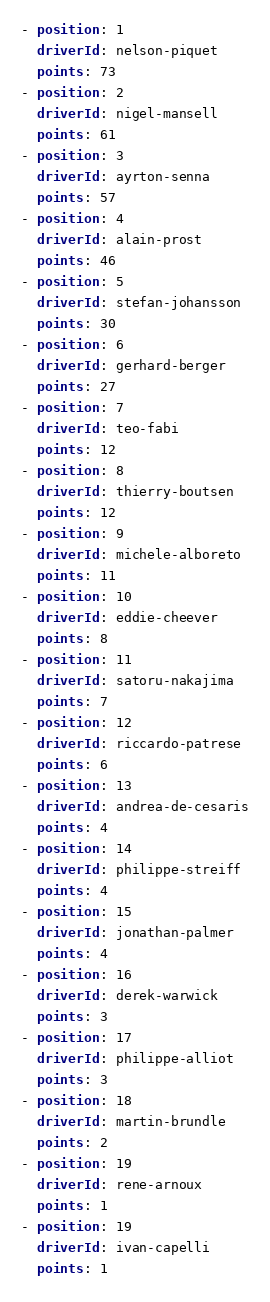Convert code to text. <code><loc_0><loc_0><loc_500><loc_500><_YAML_>- position: 1
  driverId: nelson-piquet
  points: 73
- position: 2
  driverId: nigel-mansell
  points: 61
- position: 3
  driverId: ayrton-senna
  points: 57
- position: 4
  driverId: alain-prost
  points: 46
- position: 5
  driverId: stefan-johansson
  points: 30
- position: 6
  driverId: gerhard-berger
  points: 27
- position: 7
  driverId: teo-fabi
  points: 12
- position: 8
  driverId: thierry-boutsen
  points: 12
- position: 9
  driverId: michele-alboreto
  points: 11
- position: 10
  driverId: eddie-cheever
  points: 8
- position: 11
  driverId: satoru-nakajima
  points: 7
- position: 12
  driverId: riccardo-patrese
  points: 6
- position: 13
  driverId: andrea-de-cesaris
  points: 4
- position: 14
  driverId: philippe-streiff
  points: 4
- position: 15
  driverId: jonathan-palmer
  points: 4
- position: 16
  driverId: derek-warwick
  points: 3
- position: 17
  driverId: philippe-alliot
  points: 3
- position: 18
  driverId: martin-brundle
  points: 2
- position: 19
  driverId: rene-arnoux
  points: 1
- position: 19
  driverId: ivan-capelli
  points: 1
</code> 